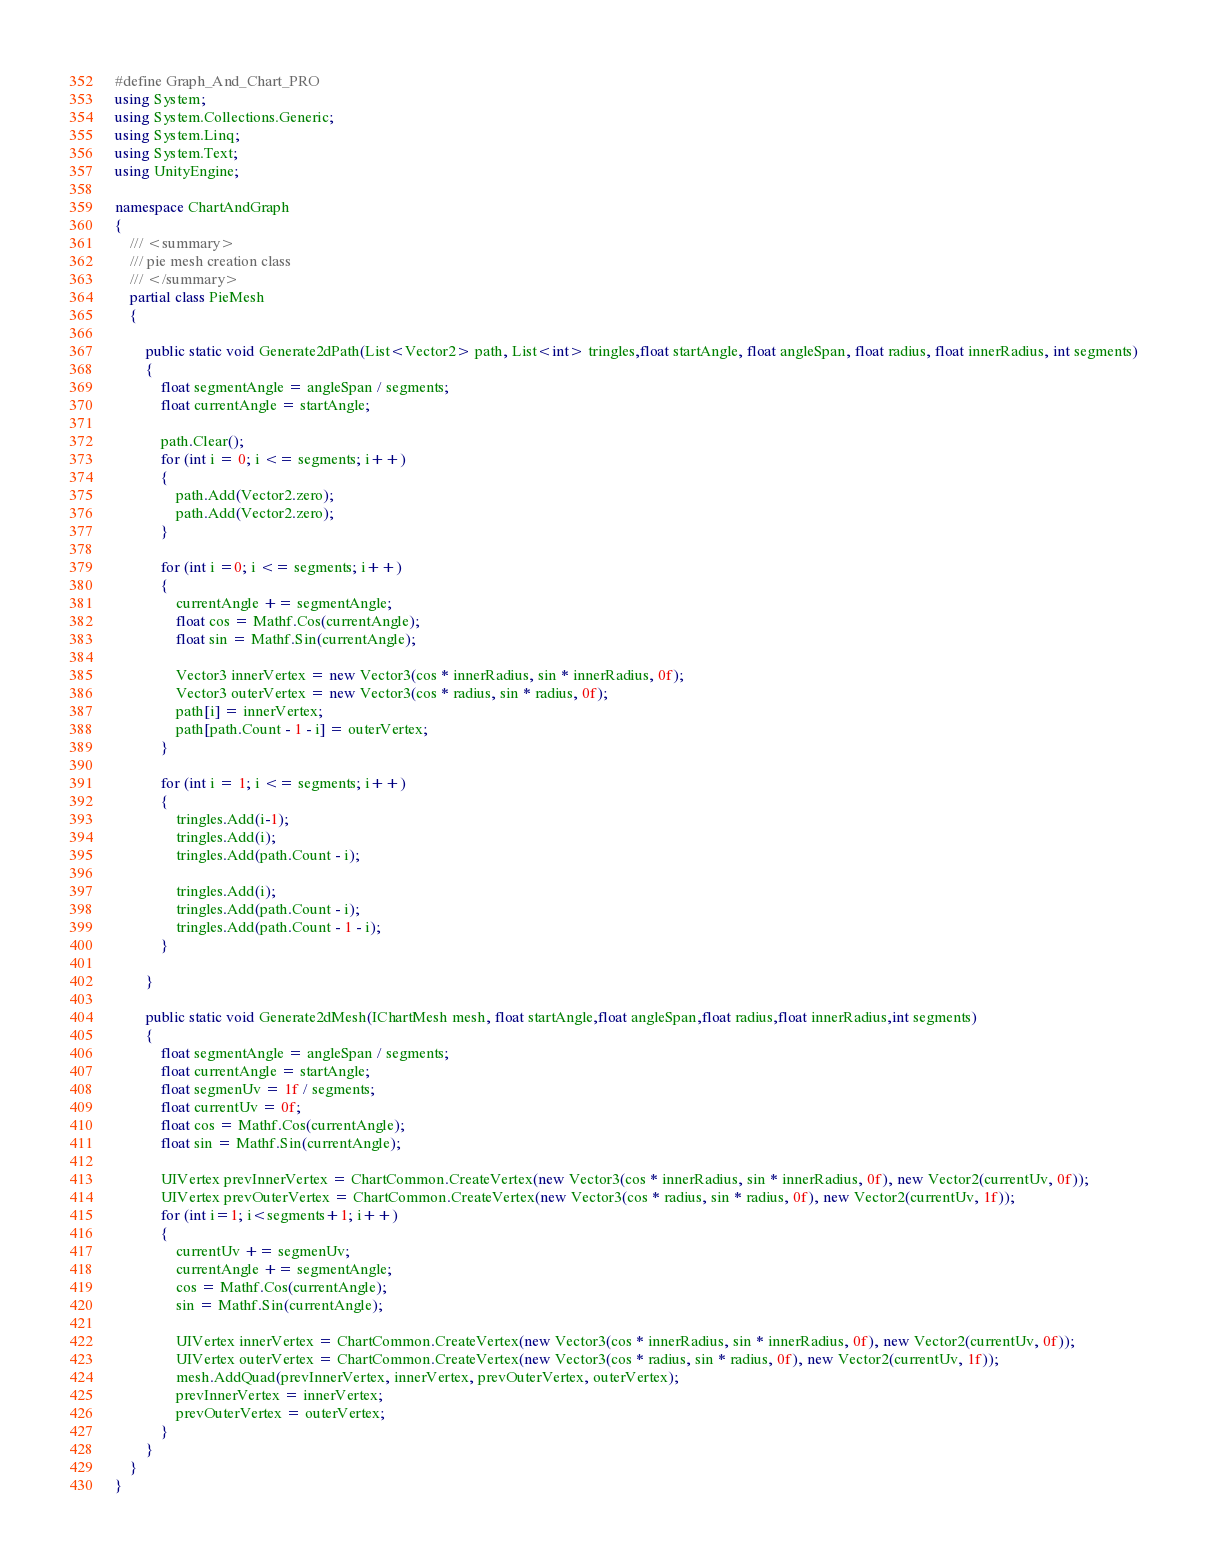Convert code to text. <code><loc_0><loc_0><loc_500><loc_500><_C#_>#define Graph_And_Chart_PRO
using System;
using System.Collections.Generic;
using System.Linq;
using System.Text;
using UnityEngine;

namespace ChartAndGraph
{
    /// <summary>
    /// pie mesh creation class
    /// </summary>
    partial class PieMesh
    {

        public static void Generate2dPath(List<Vector2> path, List<int> tringles,float startAngle, float angleSpan, float radius, float innerRadius, int segments)
        {
            float segmentAngle = angleSpan / segments;
            float currentAngle = startAngle;

            path.Clear();
            for (int i = 0; i <= segments; i++)
            {
                path.Add(Vector2.zero);
                path.Add(Vector2.zero);
            }

            for (int i =0; i <= segments; i++)
            {
                currentAngle += segmentAngle;
                float cos = Mathf.Cos(currentAngle);
                float sin = Mathf.Sin(currentAngle);

                Vector3 innerVertex = new Vector3(cos * innerRadius, sin * innerRadius, 0f);
                Vector3 outerVertex = new Vector3(cos * radius, sin * radius, 0f);
                path[i] = innerVertex;
                path[path.Count - 1 - i] = outerVertex;
            }

            for (int i = 1; i <= segments; i++)
            {
                tringles.Add(i-1);
                tringles.Add(i);
                tringles.Add(path.Count - i);

                tringles.Add(i);
                tringles.Add(path.Count - i);
                tringles.Add(path.Count - 1 - i);
            }

        }

        public static void Generate2dMesh(IChartMesh mesh, float startAngle,float angleSpan,float radius,float innerRadius,int segments)
        {
            float segmentAngle = angleSpan / segments;
            float currentAngle = startAngle;
            float segmenUv = 1f / segments;
            float currentUv = 0f; 
            float cos = Mathf.Cos(currentAngle);
            float sin = Mathf.Sin(currentAngle);

            UIVertex prevInnerVertex = ChartCommon.CreateVertex(new Vector3(cos * innerRadius, sin * innerRadius, 0f), new Vector2(currentUv, 0f));
            UIVertex prevOuterVertex = ChartCommon.CreateVertex(new Vector3(cos * radius, sin * radius, 0f), new Vector2(currentUv, 1f));
            for (int i=1; i<segments+1; i++)
            {
                currentUv += segmenUv;
                currentAngle += segmentAngle;
                cos = Mathf.Cos(currentAngle);
                sin = Mathf.Sin(currentAngle);

                UIVertex innerVertex = ChartCommon.CreateVertex(new Vector3(cos * innerRadius, sin * innerRadius, 0f), new Vector2(currentUv, 0f));
                UIVertex outerVertex = ChartCommon.CreateVertex(new Vector3(cos * radius, sin * radius, 0f), new Vector2(currentUv, 1f));
                mesh.AddQuad(prevInnerVertex, innerVertex, prevOuterVertex, outerVertex);
                prevInnerVertex = innerVertex;
                prevOuterVertex = outerVertex;
            }
        }
    }
}
</code> 